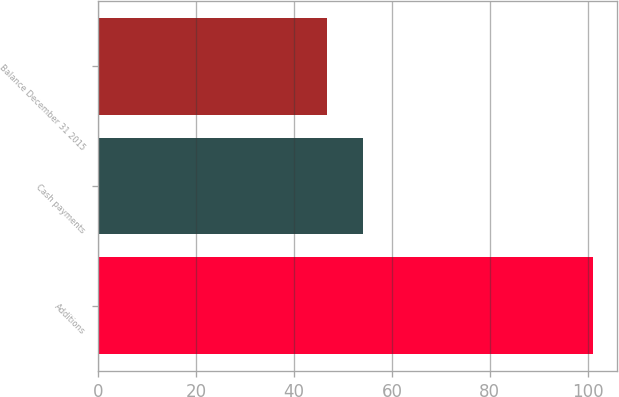Convert chart to OTSL. <chart><loc_0><loc_0><loc_500><loc_500><bar_chart><fcel>Additions<fcel>Cash payments<fcel>Balance December 31 2015<nl><fcel>101<fcel>54.1<fcel>46.8<nl></chart> 